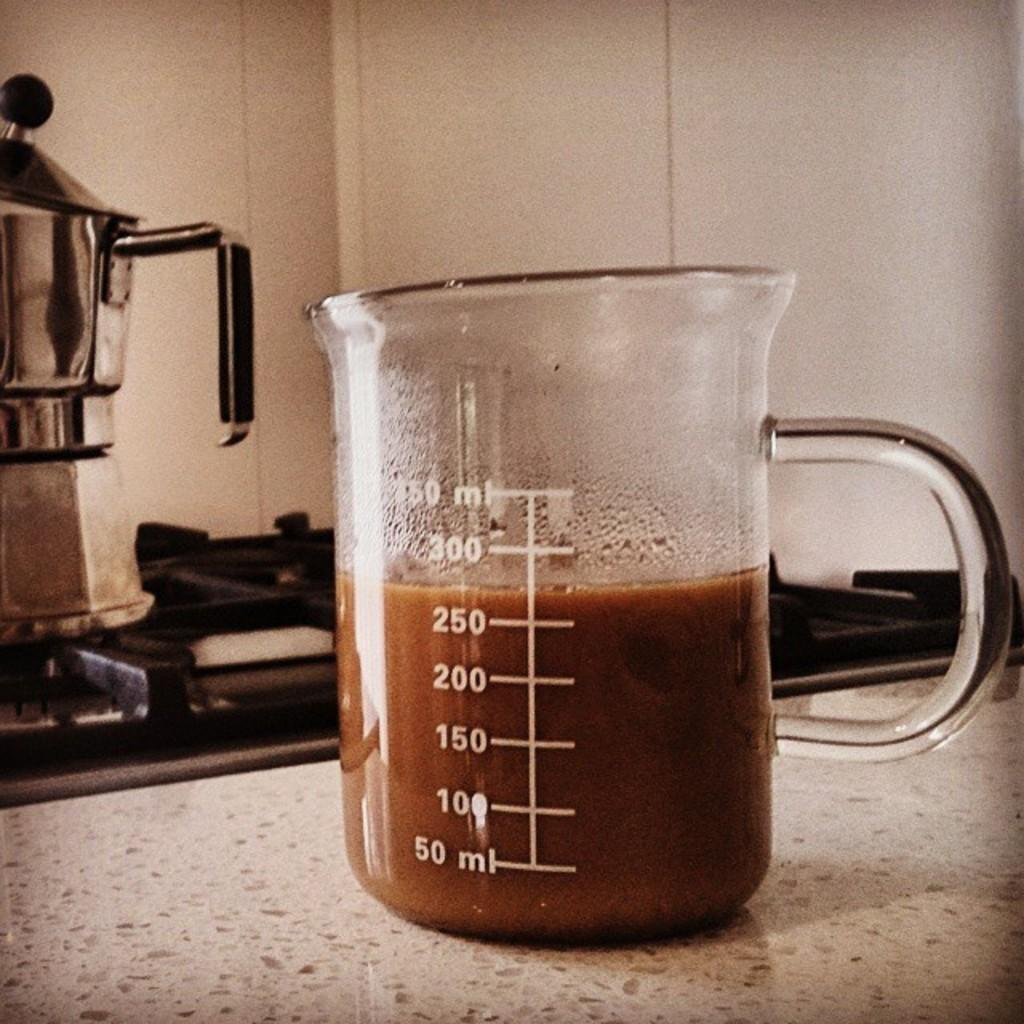<image>
Present a compact description of the photo's key features. A glass pitcher filled with approx 275 ml of coffee. 